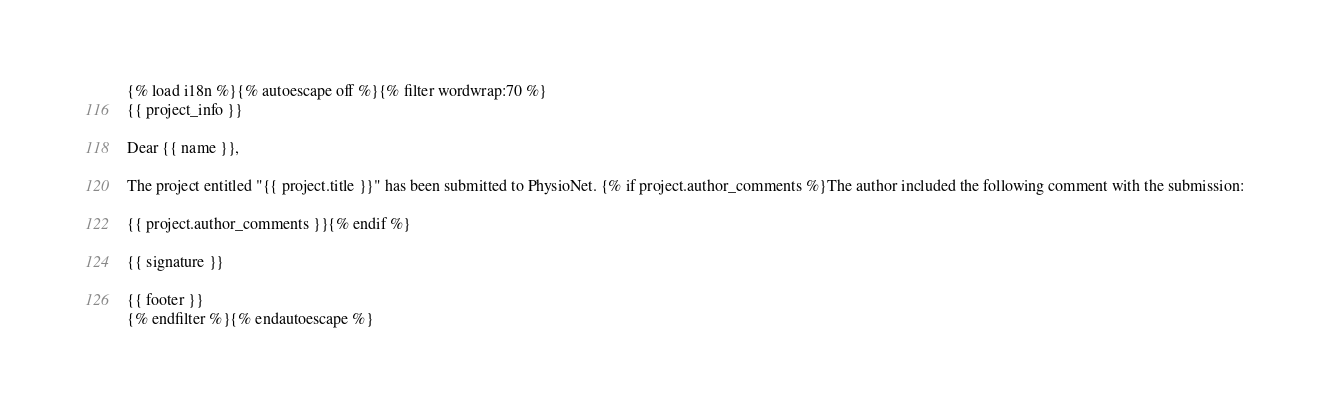<code> <loc_0><loc_0><loc_500><loc_500><_HTML_>{% load i18n %}{% autoescape off %}{% filter wordwrap:70 %}
{{ project_info }}

Dear {{ name }},

The project entitled "{{ project.title }}" has been submitted to PhysioNet. {% if project.author_comments %}The author included the following comment with the submission: 

{{ project.author_comments }}{% endif %}

{{ signature }}

{{ footer }}
{% endfilter %}{% endautoescape %}
</code> 